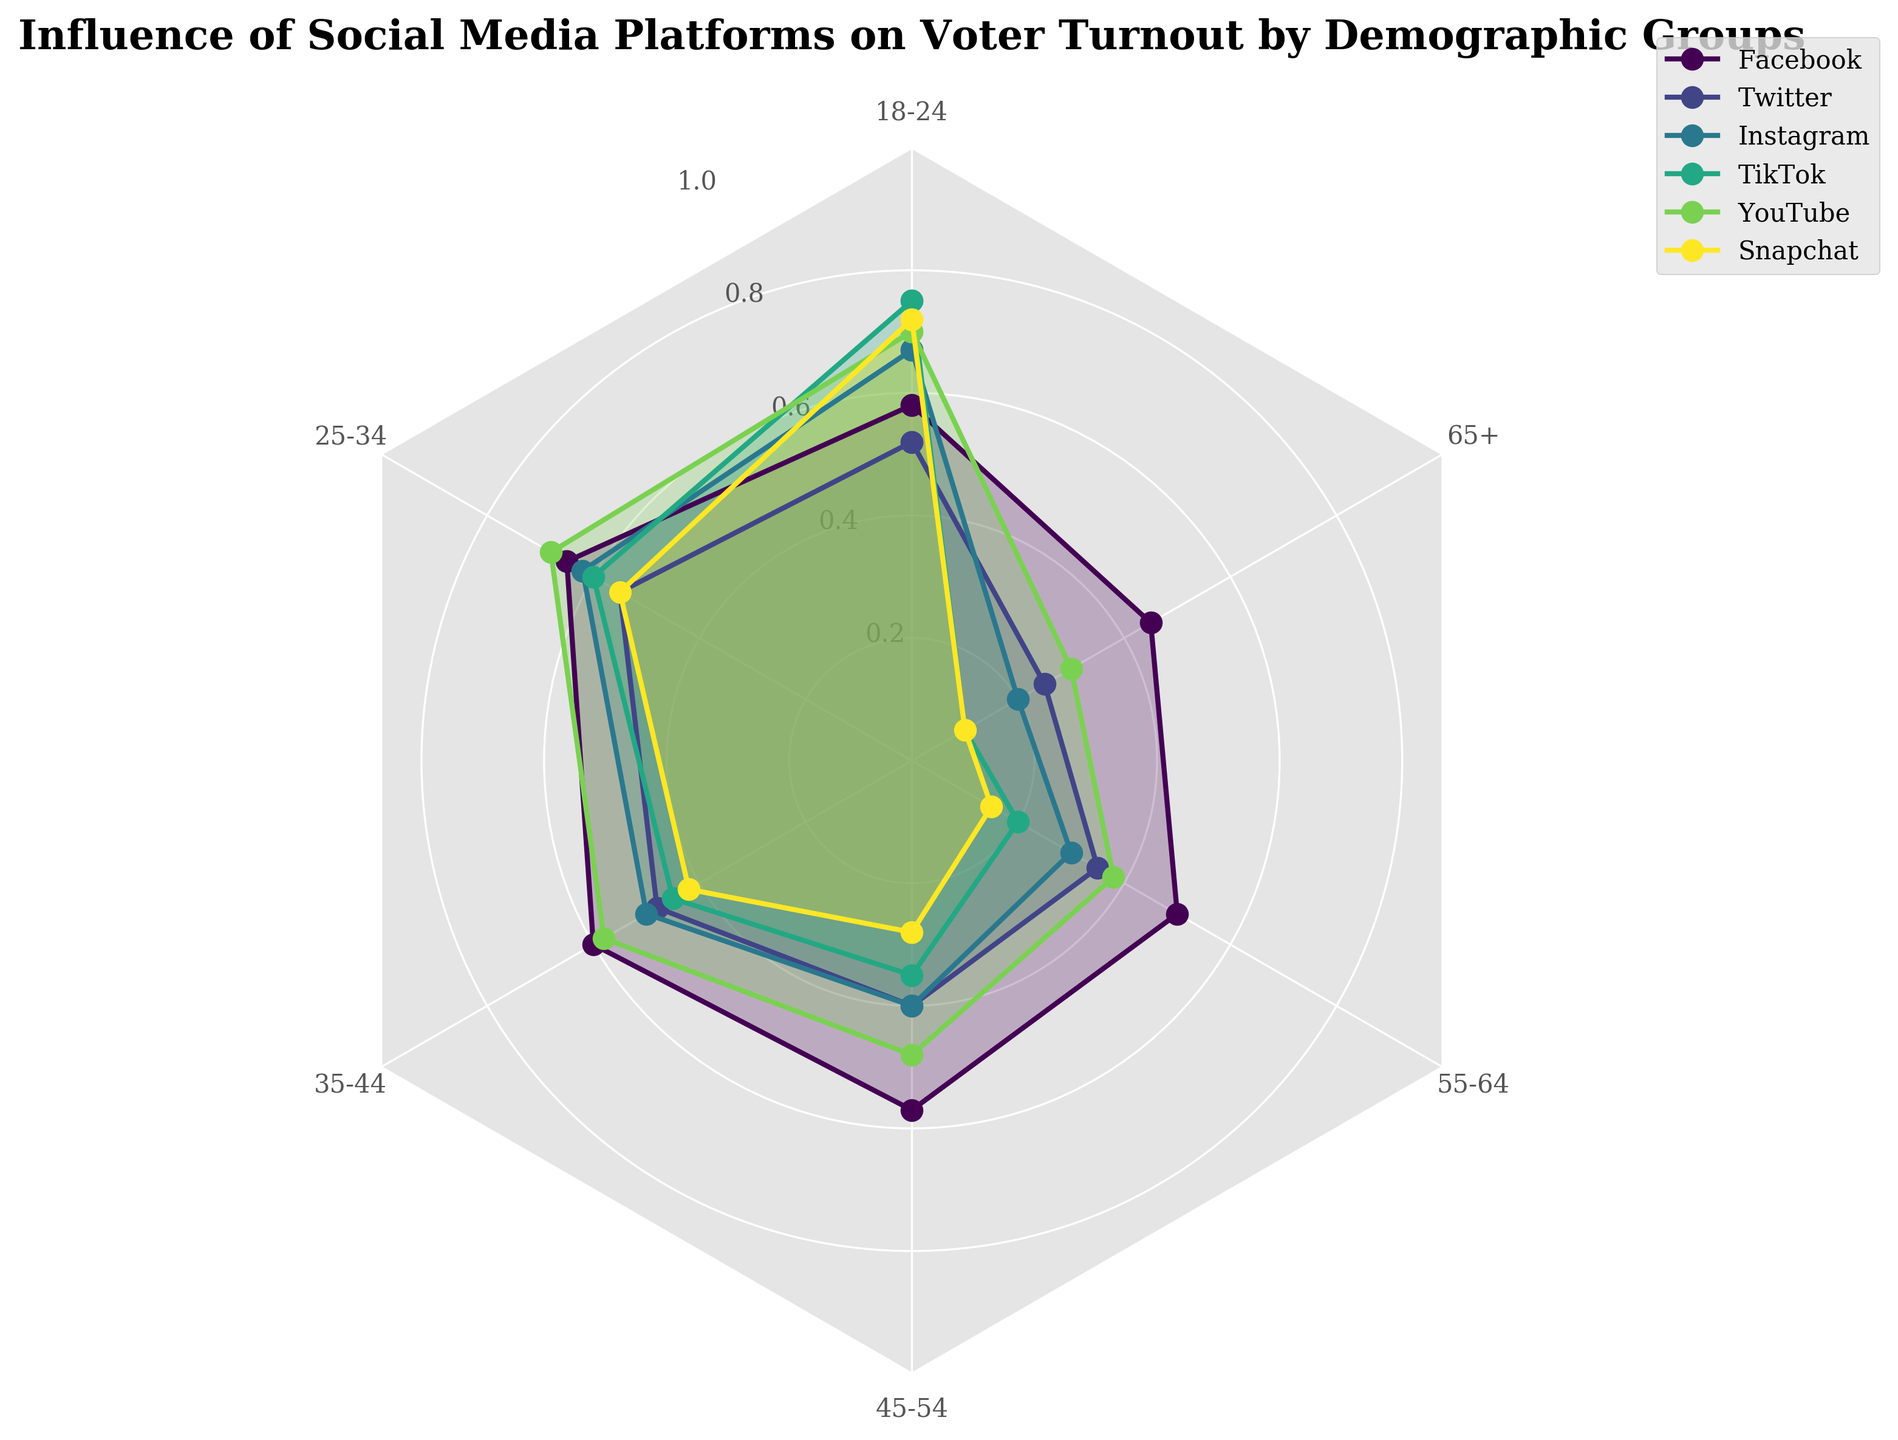What's the title of the figure? The title is usually placed at the top of the figure, often emphasized with a larger or bolder font. In this figure, it clearly states, "Influence of Social Media Platforms on Voter Turnout by Demographic Groups."
Answer: Influence of Social Media Platforms on Voter Turnout by Demographic Groups Which social media platform has the highest influence on the 18-24 age group? In a radar chart, the plotted data points nearest to the outer edge indicate higher values. For the 18-24 age group, TikTok extends to the largest radius, indicating it has the highest influence.
Answer: TikTok What is the average influence of YouTube across all demographic groups? The YouTube influence values for each demographic group are given. To find the average, sum these values and divide by the number of demographic groups. (0.70 + 0.68 + 0.58 + 0.48 + 0.38 + 0.30) / 6 = 3.12 / 6 = 0.52
Answer: 0.52 Which demographic group has the least influence from Facebook? In a radar chart, points closer to the center indicate smaller values. For Facebook, the 65+ age group's influence is the smallest, represented by the smallest radius distance.
Answer: 65+ How does the influence of Instagram on the 25-34 age group compare to its influence on the 55-64 age group? To compare values, look at the lengths of the spokes for Instagram in the 25-34 and 55-64 sections. Instagram's influence is greater in the 25-34 age group than in the 55-64 age group.
Answer: Greater in 25-34 Which age group shows the largest difference in influence between TikTok and Snapchat? Calculate the difference for each age group by subtracting the Snapchat influence from the TikTok influence. The largest difference is for the 18-24 age group: TikTok (0.75) - Snapchat (0.72) = 0.03; and similarly for other groups, finding the largest difference.
Answer: 18-24 What is the trend in influence of Twitter across the demographic groups? Observing the Twitter line in the radar chart, the influence generally decreases as the age group increases.
Answer: Decreases How many demographic groups are represented in the figure? Count the number of labeled sections around the perimeter of the radar chart. There are six labeled sections, representing different demographic groups.
Answer: Six Compare the influence of YouTube and Instagram on the 35-44 age group. Which one is higher? Look at the lengths of the spokes for YouTube and Instagram in the 35-44 section. YouTube has a value of 0.58, and Instagram has 0.50, so YouTube's influence is higher.
Answer: YouTube 